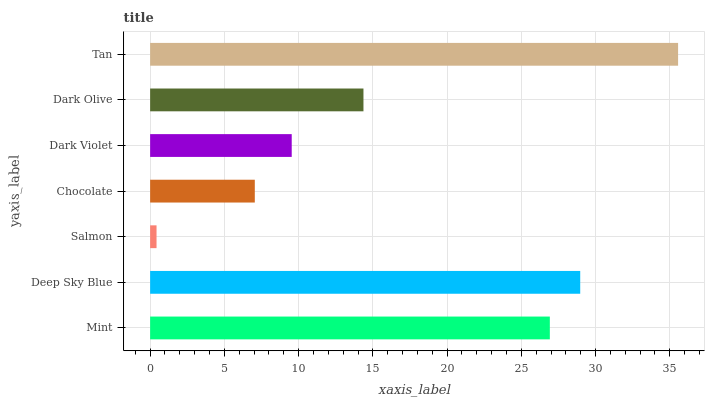Is Salmon the minimum?
Answer yes or no. Yes. Is Tan the maximum?
Answer yes or no. Yes. Is Deep Sky Blue the minimum?
Answer yes or no. No. Is Deep Sky Blue the maximum?
Answer yes or no. No. Is Deep Sky Blue greater than Mint?
Answer yes or no. Yes. Is Mint less than Deep Sky Blue?
Answer yes or no. Yes. Is Mint greater than Deep Sky Blue?
Answer yes or no. No. Is Deep Sky Blue less than Mint?
Answer yes or no. No. Is Dark Olive the high median?
Answer yes or no. Yes. Is Dark Olive the low median?
Answer yes or no. Yes. Is Mint the high median?
Answer yes or no. No. Is Dark Violet the low median?
Answer yes or no. No. 